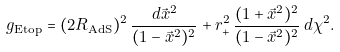<formula> <loc_0><loc_0><loc_500><loc_500>g _ { \text {Etop} } = ( 2 R _ { \text {AdS} } ) ^ { 2 } \, \frac { d \vec { x } ^ { 2 } } { ( 1 - \vec { x } ^ { 2 } ) ^ { 2 } } + r _ { + } ^ { 2 } \, \frac { ( 1 + \vec { x } ^ { 2 } ) ^ { 2 } } { ( 1 - \vec { x } ^ { 2 } ) ^ { 2 } } \, d \chi ^ { 2 } .</formula> 